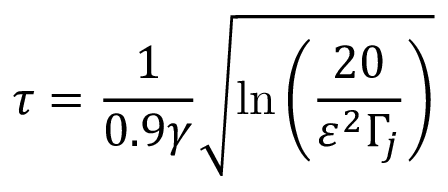<formula> <loc_0><loc_0><loc_500><loc_500>\tau = \frac { 1 } { 0 . 9 \gamma } \sqrt { \ln \left ( \frac { 2 0 } { \varepsilon ^ { 2 } \Gamma _ { j } } \right ) }</formula> 